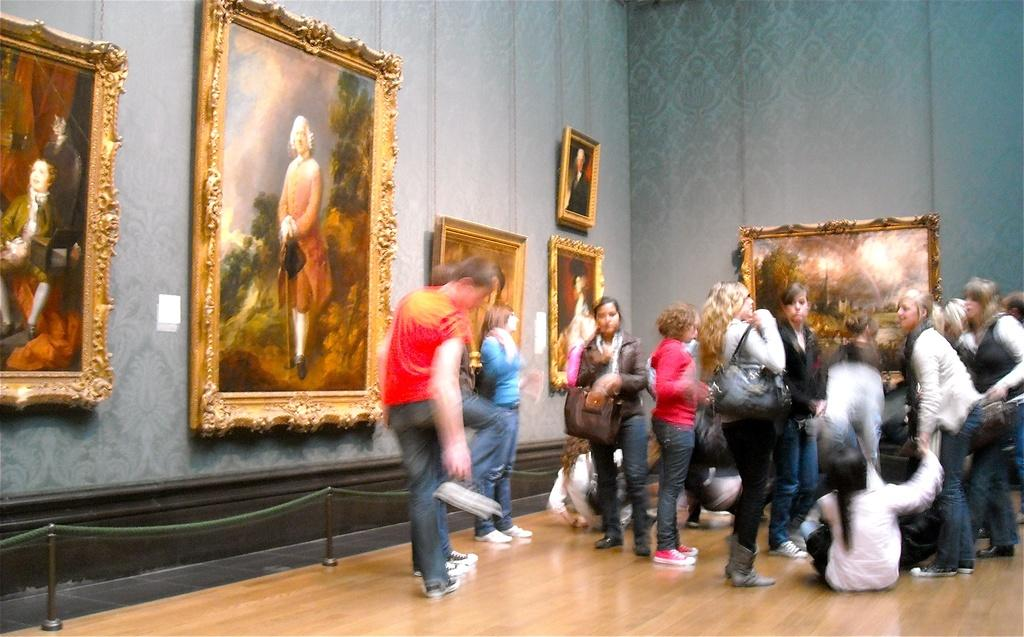What type of structure can be seen in the image? There is a wall in the image. What is hanging on the wall? There are photo frames in the image. Are there any living beings present in the image? Yes, there are people present in the image. What type of cough medicine is being advertised in the photo frames? There is no cough medicine or advertisement present in the image; it only features a wall with photo frames and people. 